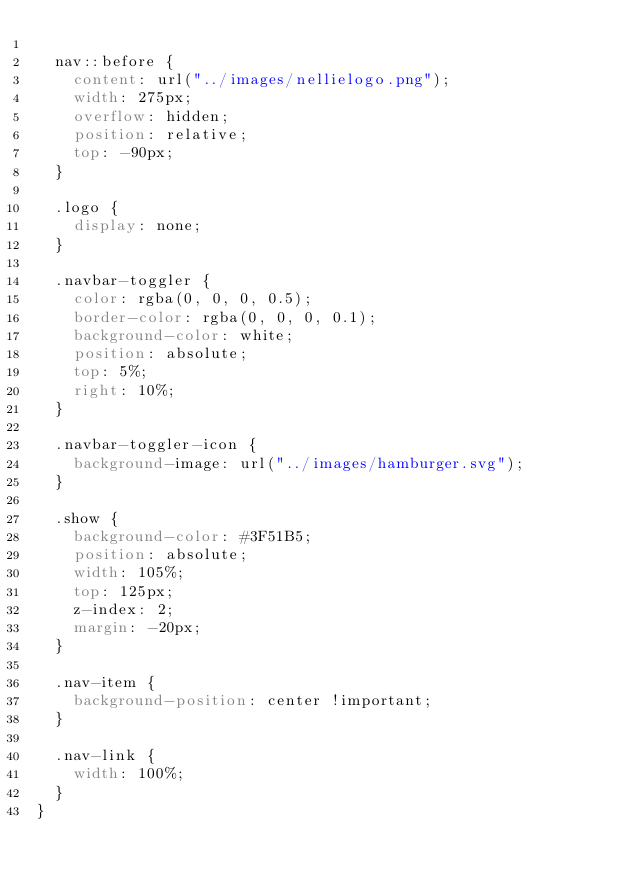<code> <loc_0><loc_0><loc_500><loc_500><_CSS_>
  nav::before {
    content: url("../images/nellielogo.png");
    width: 275px;
    overflow: hidden;
    position: relative;
    top: -90px;
  }

  .logo {
    display: none;
  }

  .navbar-toggler {
    color: rgba(0, 0, 0, 0.5);
    border-color: rgba(0, 0, 0, 0.1);
    background-color: white;
    position: absolute;
    top: 5%;
    right: 10%;
  }

  .navbar-toggler-icon {
    background-image: url("../images/hamburger.svg");
  }

  .show {
    background-color: #3F51B5;
    position: absolute;
    width: 105%;
    top: 125px;
    z-index: 2;
    margin: -20px;
  }

  .nav-item {
    background-position: center !important;
  }

  .nav-link {
    width: 100%;
  }
}
</code> 